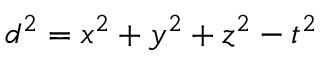<formula> <loc_0><loc_0><loc_500><loc_500>d ^ { 2 } = x ^ { 2 } + y ^ { 2 } + z ^ { 2 } - t ^ { 2 }</formula> 